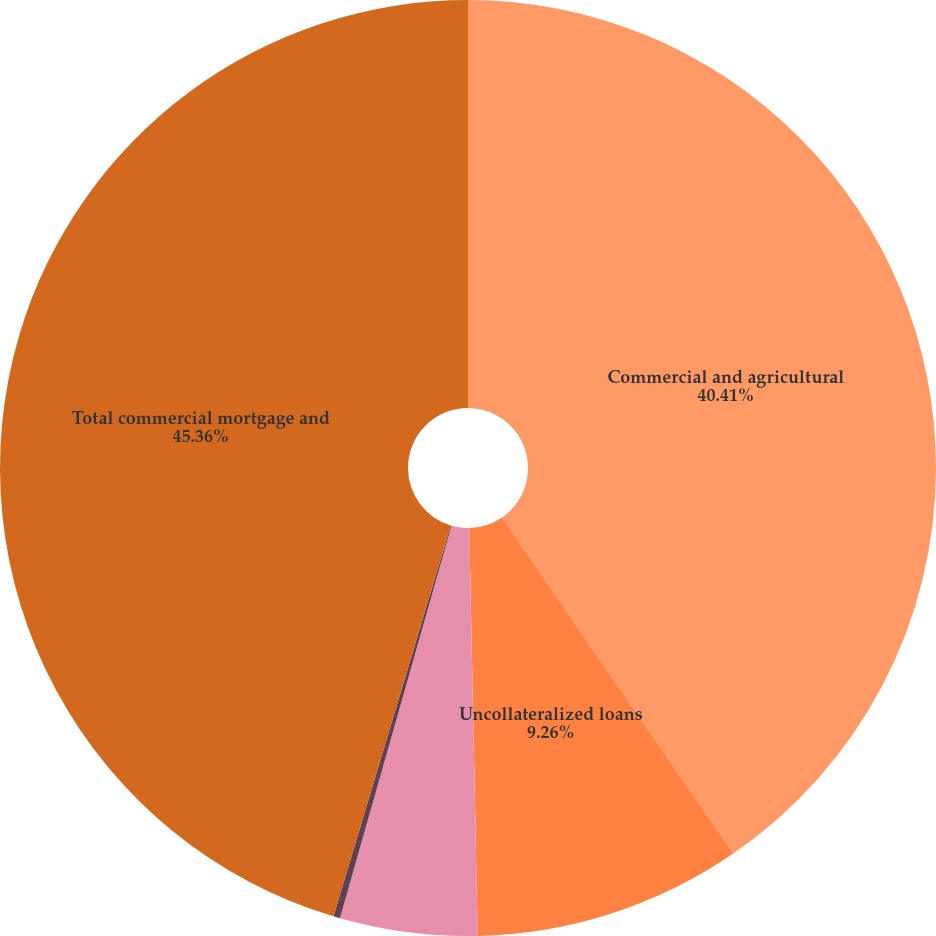Convert chart. <chart><loc_0><loc_0><loc_500><loc_500><pie_chart><fcel>Commercial and agricultural<fcel>Uncollateralized loans<fcel>Residential property loans<fcel>Other collateralized loans<fcel>Total commercial mortgage and<nl><fcel>40.41%<fcel>9.26%<fcel>4.74%<fcel>0.23%<fcel>45.36%<nl></chart> 